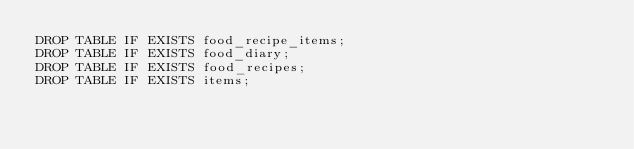Convert code to text. <code><loc_0><loc_0><loc_500><loc_500><_SQL_>DROP TABLE IF EXISTS food_recipe_items;
DROP TABLE IF EXISTS food_diary;
DROP TABLE IF EXISTS food_recipes;
DROP TABLE IF EXISTS items;
</code> 